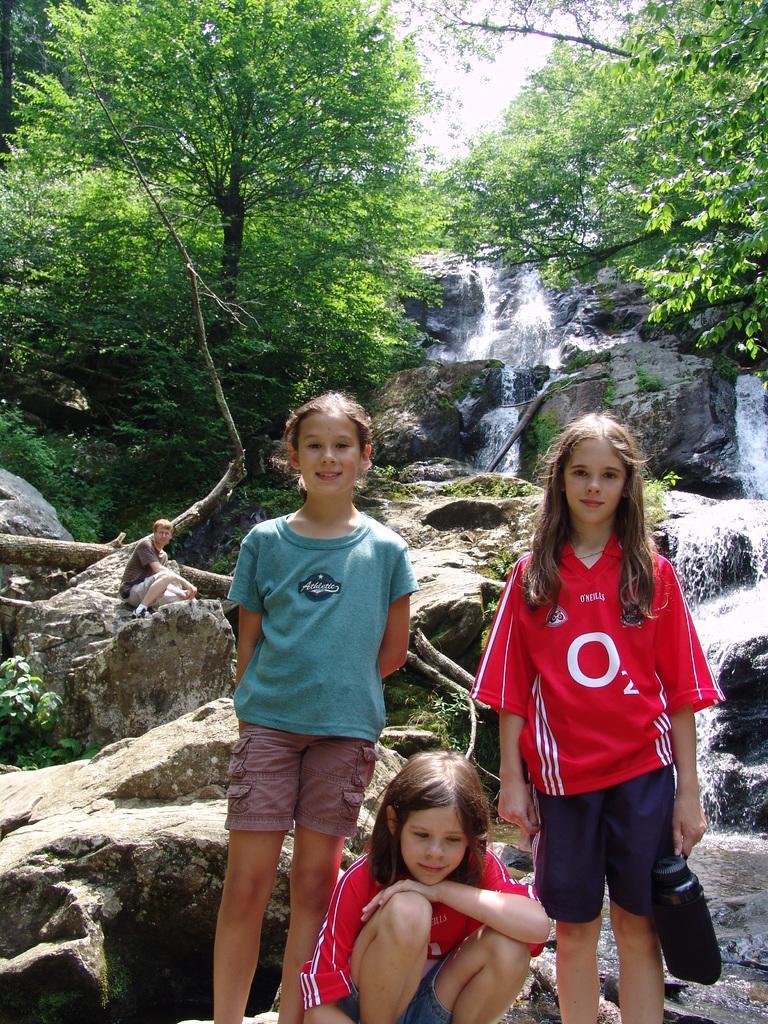In one or two sentences, can you explain what this image depicts? In front of the image there is a girl sitting on the rock. Beside her there are two other girls standing. Behind them there is a person sitting on the rock. There are plants. There is water flowing on the rocks. In the background of the image there are trees. At the top of the image there is sky. 